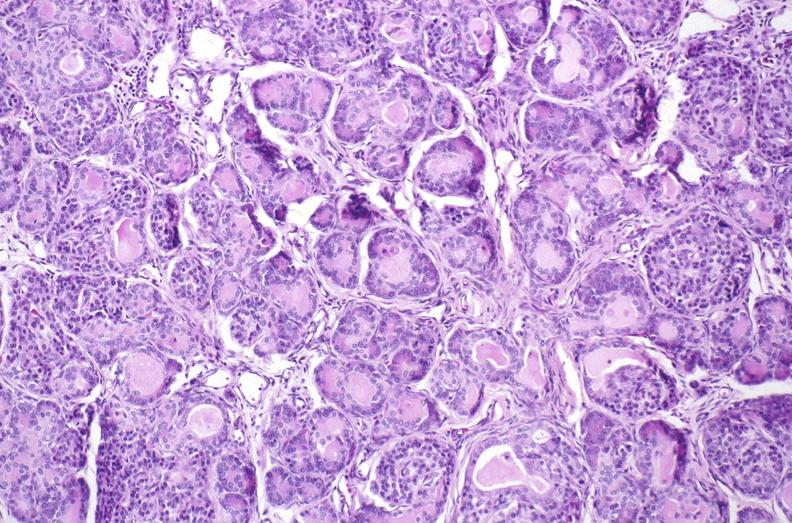s surface of nodes seen externally in slide present?
Answer the question using a single word or phrase. No 